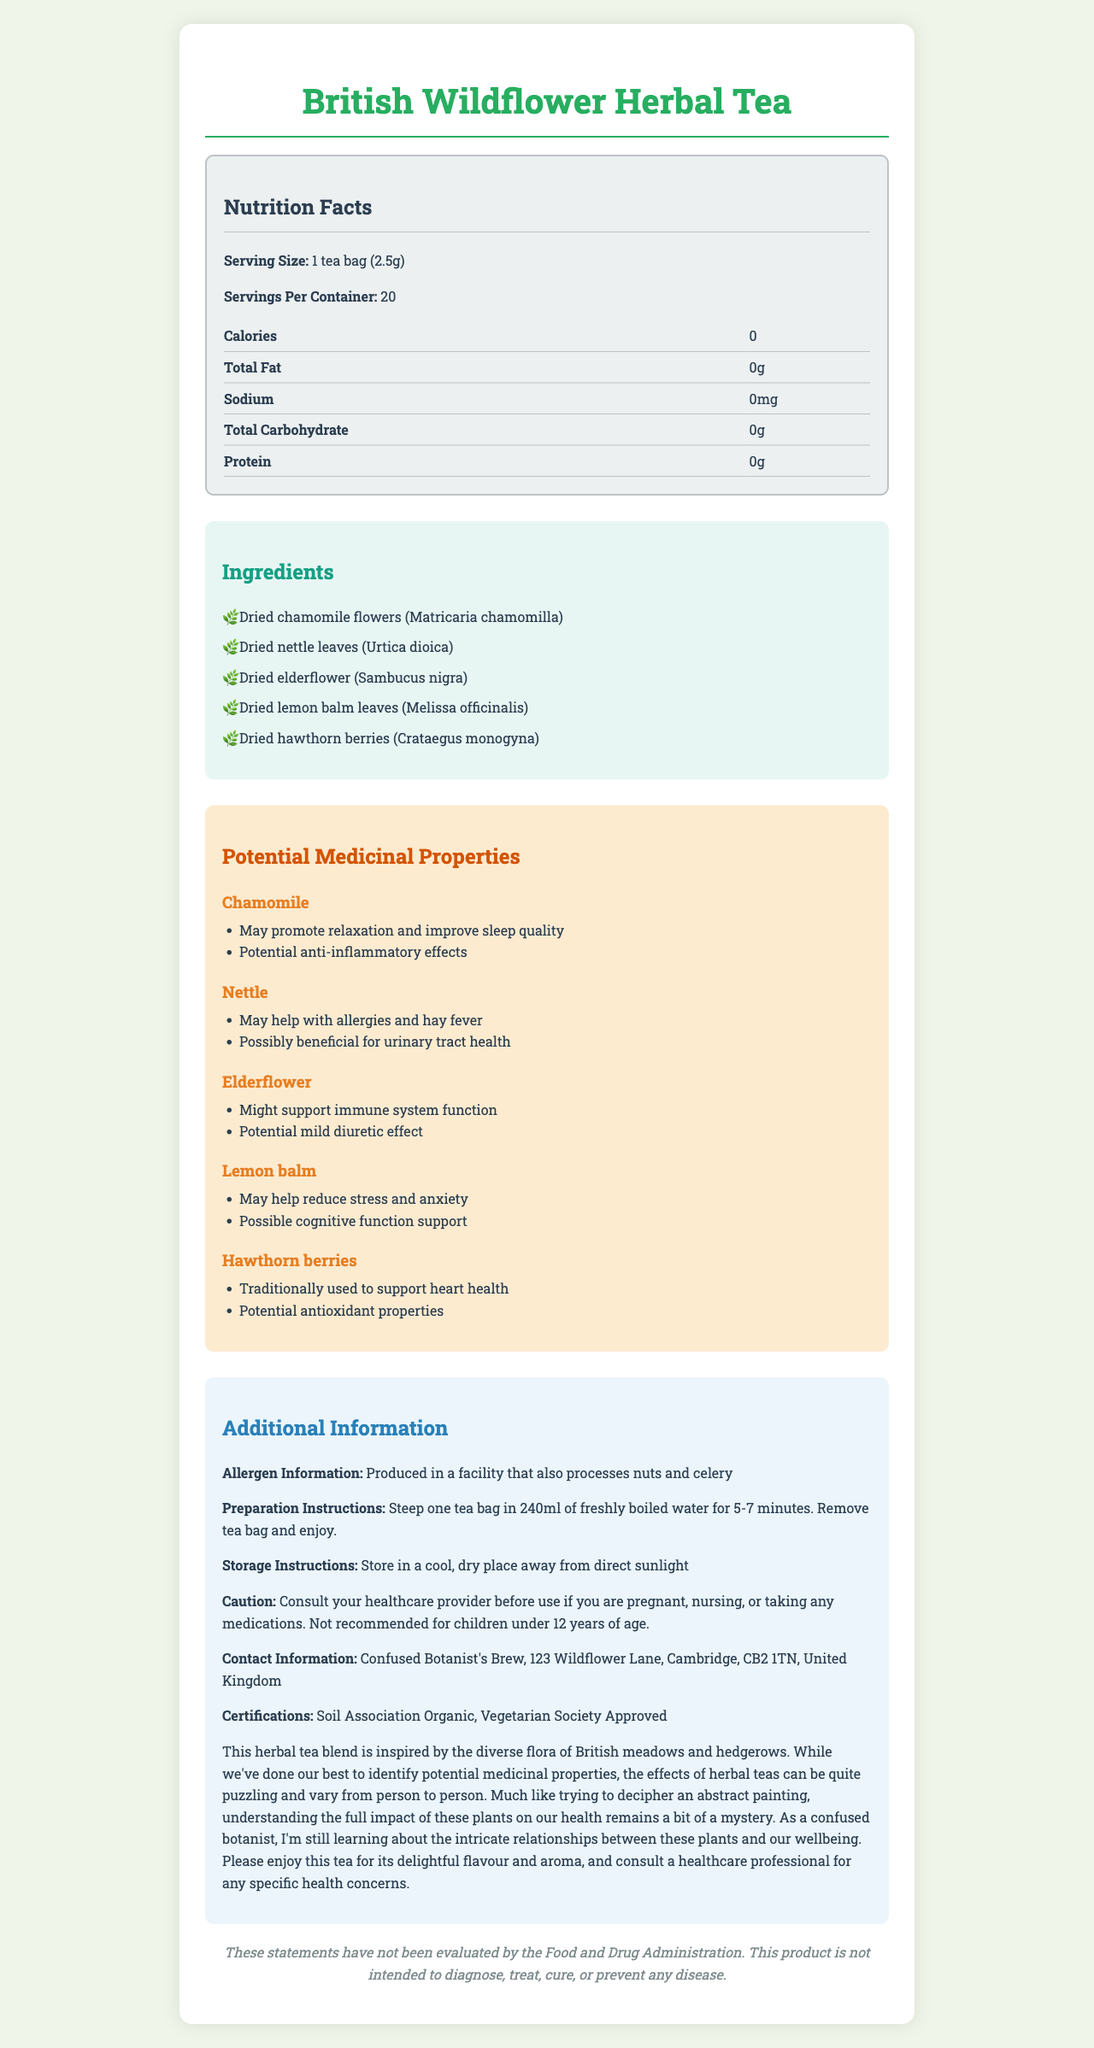What is the serving size for the British Wildflower Herbal Tea? The serving size is explicitly stated as "1 tea bag (2.5g)" in the document.
Answer: 1 tea bag (2.5g) How many servings are in one container of the tea? The document notes that there are 20 servings per container.
Answer: 20 What is the calorie content of one serving of this herbal tea? The document specifies that the calories per serving are 0.
Answer: 0 Name two ingredients in the British Wildflower Herbal Tea. The ingredients listed in the document include Dried chamomile flowers and Dried nettle leaves, among others.
Answer: Dried chamomile flowers and Dried nettle leaves What potential medicinal property does elderflower have? The document highlights that elderflower might support immune system function.
Answer: Might support immune system function Which of the following ingredients is recommended for heart health? A. Chamomile B. Nettle C. Hawthorn berries The document states that hawthorn berries are traditionally used to support heart health.
Answer: C. Hawthorn berries How should you prepare the British Wildflower Herbal Tea? A. Steep in cold water for 10 minutes B. Brew in milk for 2 minutes C. Steep in freshly boiled water for 5-7 minutes The preparation instructions clearly state to steep one tea bag in 240ml of freshly boiled water for 5-7 minutes.
Answer: C. Steep in freshly boiled water for 5-7 minutes True or False: This tea contains sodium. The nutrition facts section states that sodium content is 0mg.
Answer: False Summarize the main idea of the British Wildflower Herbal Tea nutrition facts label. The document contains comprehensive information about the herbal tea, its ingredients, medicinal benefits, and guidelines for consumption.
Answer: This label provides details about the British Wildflower Herbal Tea, including serving size, nutritional content, ingredient list, potential medicinal properties, allergen information, preparation and storage instructions, caution notes, and certifications. It also comments on the variability of herbal tea effects and encourages consulting a healthcare professional for specific health concerns. What is the contact address for the manufacturer of the British Wildflower Herbal Tea? The contact information is listed in the additional information section of the document.
Answer: Confused Botanist's Brew, 123 Wildflower Lane, Cambridge, CB2 1TN, United Kingdom Is the British Wildflower Herbal Tea suitable for children under 12 years of age? The caution section specifies that the tea is not recommended for children under 12 years of age.
Answer: No What certifications does the British Wildflower Herbal Tea have? The certifications listed are Soil Association Organic and Vegetarian Society Approved.
Answer: Soil Association Organic, Vegetarian Society Approved What is the recommended storage condition for the British Wildflower Herbal Tea? The storage instructions state to store the tea in a cool, dry place away from direct sunlight.
Answer: Store in a cool, dry place away from direct sunlight Which ingredient in the British Wildflower Herbal Tea might help reduce stress and anxiety? Lemon balm is noted in the medicinal properties section as potentially helping to reduce stress and anxiety.
Answer: Lemon balm How many mg of cholesterol does the tea contain? The document does not provide any information about cholesterol content.
Answer: Cannot be determined 